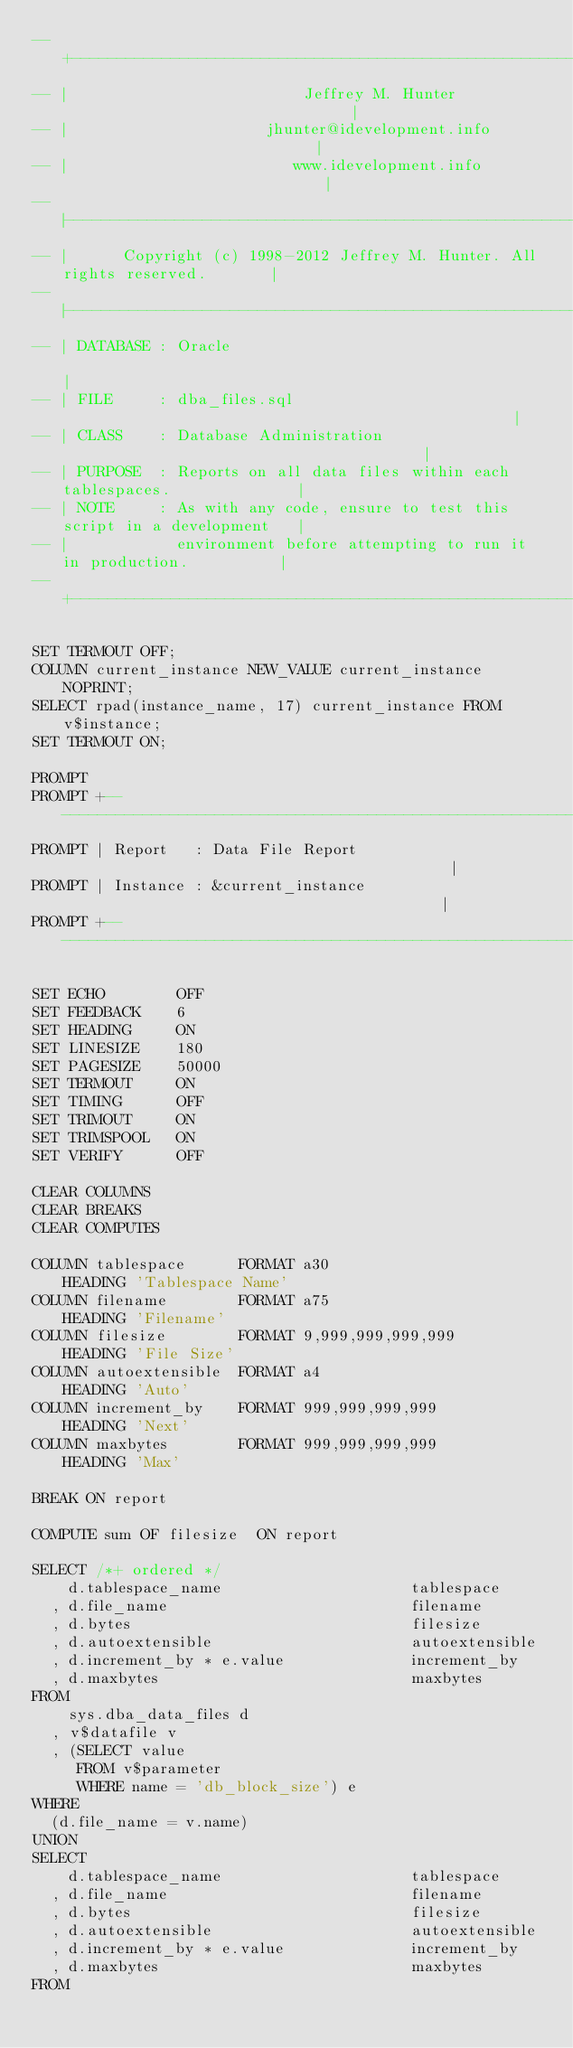Convert code to text. <code><loc_0><loc_0><loc_500><loc_500><_SQL_>-- +----------------------------------------------------------------------------+
-- |                          Jeffrey M. Hunter                                 |
-- |                      jhunter@idevelopment.info                             |
-- |                         www.idevelopment.info                              |
-- |----------------------------------------------------------------------------|
-- |      Copyright (c) 1998-2012 Jeffrey M. Hunter. All rights reserved.       |
-- |----------------------------------------------------------------------------|
-- | DATABASE : Oracle                                                          |
-- | FILE     : dba_files.sql                                                   |
-- | CLASS    : Database Administration                                         |
-- | PURPOSE  : Reports on all data files within each tablespaces.              |
-- | NOTE     : As with any code, ensure to test this script in a development   |
-- |            environment before attempting to run it in production.          |
-- +----------------------------------------------------------------------------+

SET TERMOUT OFF;
COLUMN current_instance NEW_VALUE current_instance NOPRINT;
SELECT rpad(instance_name, 17) current_instance FROM v$instance;
SET TERMOUT ON;

PROMPT 
PROMPT +------------------------------------------------------------------------+
PROMPT | Report   : Data File Report                                            |
PROMPT | Instance : &current_instance                                           |
PROMPT +------------------------------------------------------------------------+

SET ECHO        OFF
SET FEEDBACK    6
SET HEADING     ON
SET LINESIZE    180
SET PAGESIZE    50000
SET TERMOUT     ON
SET TIMING      OFF
SET TRIMOUT     ON
SET TRIMSPOOL   ON
SET VERIFY      OFF

CLEAR COLUMNS
CLEAR BREAKS
CLEAR COMPUTES

COLUMN tablespace      FORMAT a30                   HEADING 'Tablespace Name'
COLUMN filename        FORMAT a75                   HEADING 'Filename'
COLUMN filesize        FORMAT 9,999,999,999,999     HEADING 'File Size'
COLUMN autoextensible  FORMAT a4                    HEADING 'Auto'
COLUMN increment_by    FORMAT 999,999,999,999       HEADING 'Next'
COLUMN maxbytes        FORMAT 999,999,999,999       HEADING 'Max'

BREAK ON report

COMPUTE sum OF filesize  ON report

SELECT /*+ ordered */
    d.tablespace_name                     tablespace
  , d.file_name                           filename
  , d.bytes                               filesize
  , d.autoextensible                      autoextensible
  , d.increment_by * e.value              increment_by
  , d.maxbytes                            maxbytes
FROM
    sys.dba_data_files d
  , v$datafile v
  , (SELECT value
     FROM v$parameter 
     WHERE name = 'db_block_size') e
WHERE
  (d.file_name = v.name)
UNION
SELECT
    d.tablespace_name                     tablespace 
  , d.file_name                           filename
  , d.bytes                               filesize
  , d.autoextensible                      autoextensible
  , d.increment_by * e.value              increment_by
  , d.maxbytes                            maxbytes
FROM</code> 